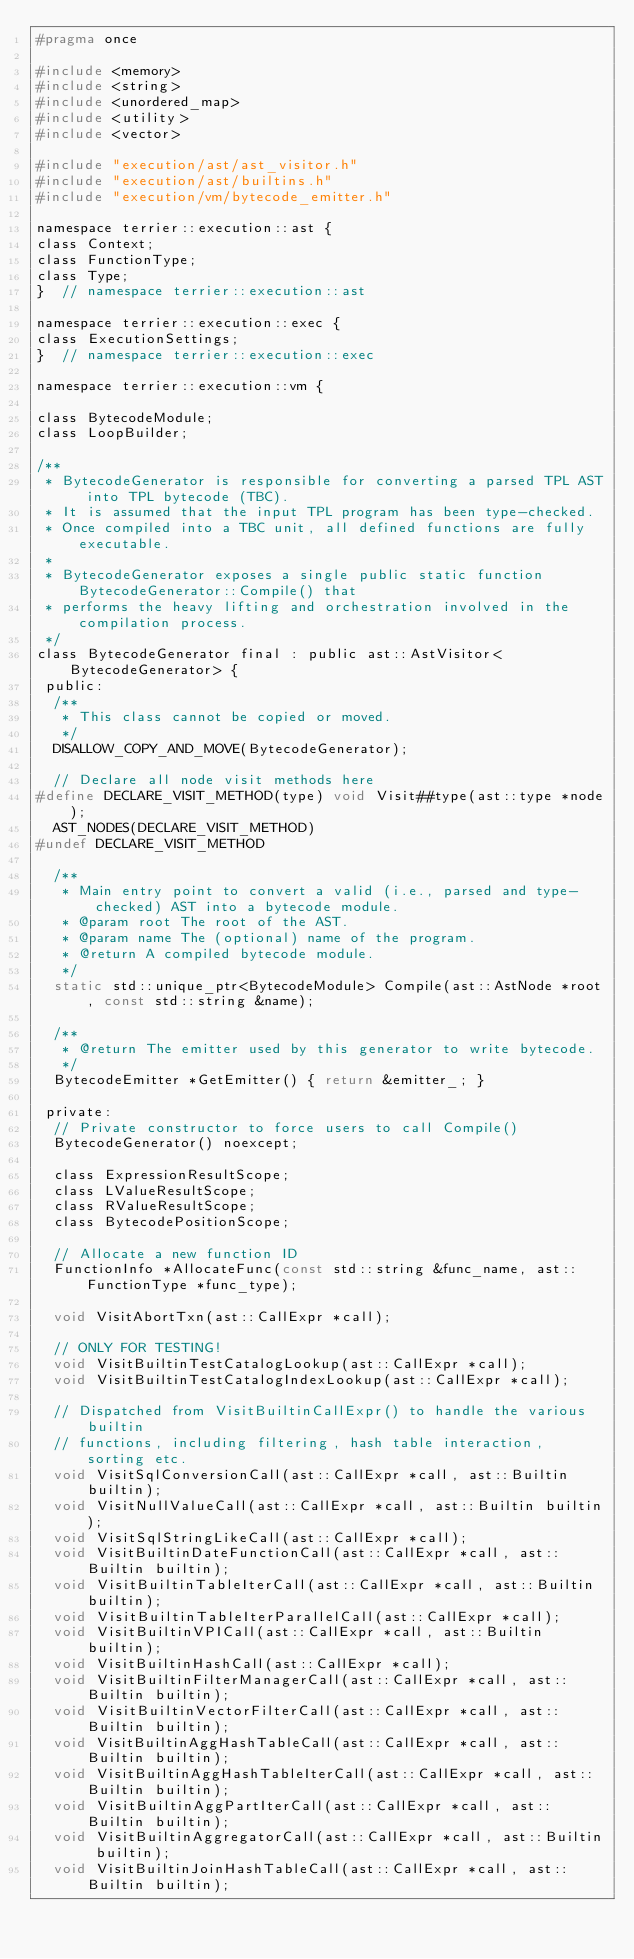Convert code to text. <code><loc_0><loc_0><loc_500><loc_500><_C_>#pragma once

#include <memory>
#include <string>
#include <unordered_map>
#include <utility>
#include <vector>

#include "execution/ast/ast_visitor.h"
#include "execution/ast/builtins.h"
#include "execution/vm/bytecode_emitter.h"

namespace terrier::execution::ast {
class Context;
class FunctionType;
class Type;
}  // namespace terrier::execution::ast

namespace terrier::execution::exec {
class ExecutionSettings;
}  // namespace terrier::execution::exec

namespace terrier::execution::vm {

class BytecodeModule;
class LoopBuilder;

/**
 * BytecodeGenerator is responsible for converting a parsed TPL AST into TPL bytecode (TBC).
 * It is assumed that the input TPL program has been type-checked.
 * Once compiled into a TBC unit, all defined functions are fully executable.
 *
 * BytecodeGenerator exposes a single public static function BytecodeGenerator::Compile() that
 * performs the heavy lifting and orchestration involved in the compilation process.
 */
class BytecodeGenerator final : public ast::AstVisitor<BytecodeGenerator> {
 public:
  /**
   * This class cannot be copied or moved.
   */
  DISALLOW_COPY_AND_MOVE(BytecodeGenerator);

  // Declare all node visit methods here
#define DECLARE_VISIT_METHOD(type) void Visit##type(ast::type *node);
  AST_NODES(DECLARE_VISIT_METHOD)
#undef DECLARE_VISIT_METHOD

  /**
   * Main entry point to convert a valid (i.e., parsed and type-checked) AST into a bytecode module.
   * @param root The root of the AST.
   * @param name The (optional) name of the program.
   * @return A compiled bytecode module.
   */
  static std::unique_ptr<BytecodeModule> Compile(ast::AstNode *root, const std::string &name);

  /**
   * @return The emitter used by this generator to write bytecode.
   */
  BytecodeEmitter *GetEmitter() { return &emitter_; }

 private:
  // Private constructor to force users to call Compile()
  BytecodeGenerator() noexcept;

  class ExpressionResultScope;
  class LValueResultScope;
  class RValueResultScope;
  class BytecodePositionScope;

  // Allocate a new function ID
  FunctionInfo *AllocateFunc(const std::string &func_name, ast::FunctionType *func_type);

  void VisitAbortTxn(ast::CallExpr *call);

  // ONLY FOR TESTING!
  void VisitBuiltinTestCatalogLookup(ast::CallExpr *call);
  void VisitBuiltinTestCatalogIndexLookup(ast::CallExpr *call);

  // Dispatched from VisitBuiltinCallExpr() to handle the various builtin
  // functions, including filtering, hash table interaction, sorting etc.
  void VisitSqlConversionCall(ast::CallExpr *call, ast::Builtin builtin);
  void VisitNullValueCall(ast::CallExpr *call, ast::Builtin builtin);
  void VisitSqlStringLikeCall(ast::CallExpr *call);
  void VisitBuiltinDateFunctionCall(ast::CallExpr *call, ast::Builtin builtin);
  void VisitBuiltinTableIterCall(ast::CallExpr *call, ast::Builtin builtin);
  void VisitBuiltinTableIterParallelCall(ast::CallExpr *call);
  void VisitBuiltinVPICall(ast::CallExpr *call, ast::Builtin builtin);
  void VisitBuiltinHashCall(ast::CallExpr *call);
  void VisitBuiltinFilterManagerCall(ast::CallExpr *call, ast::Builtin builtin);
  void VisitBuiltinVectorFilterCall(ast::CallExpr *call, ast::Builtin builtin);
  void VisitBuiltinAggHashTableCall(ast::CallExpr *call, ast::Builtin builtin);
  void VisitBuiltinAggHashTableIterCall(ast::CallExpr *call, ast::Builtin builtin);
  void VisitBuiltinAggPartIterCall(ast::CallExpr *call, ast::Builtin builtin);
  void VisitBuiltinAggregatorCall(ast::CallExpr *call, ast::Builtin builtin);
  void VisitBuiltinJoinHashTableCall(ast::CallExpr *call, ast::Builtin builtin);</code> 